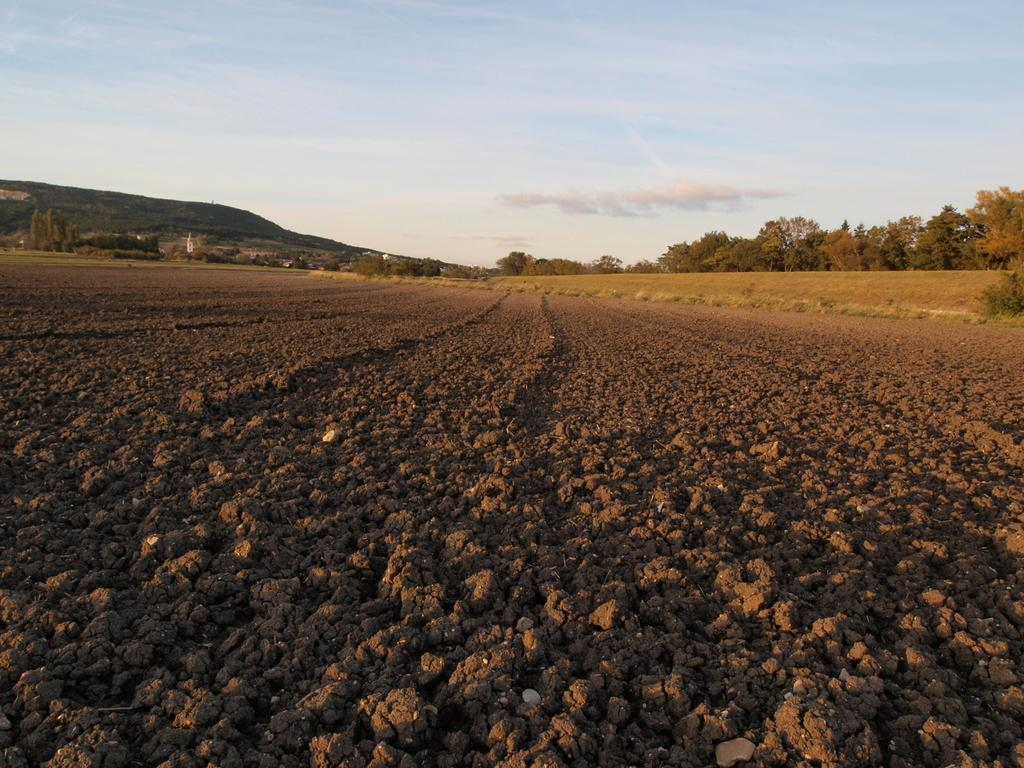What can be seen in the foreground of the image? There is land in the foreground of the image. What is visible in the background of the image? There are trees, mountains, and the sky in the background of the image. Can you describe the sky in the image? The sky is visible in the background of the image, and there is a cloud present. Can you see any snakes slithering through the trees in the image? There are no snakes visible in the image; it only shows trees, mountains, and the sky. What type of teeth can be seen on the mountains in the image? There are no teeth present in the image, as mountains do not have teeth. 